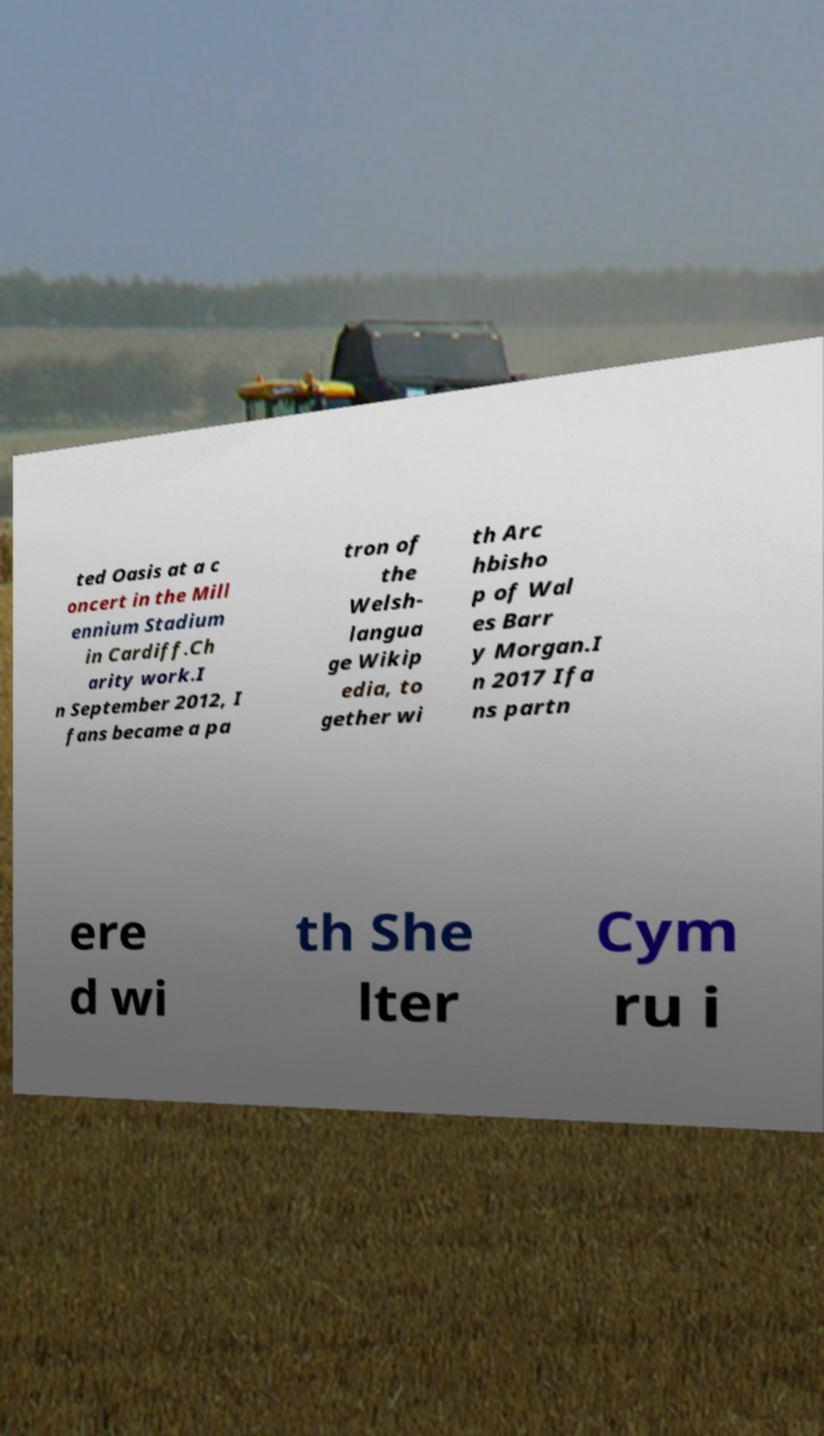Could you assist in decoding the text presented in this image and type it out clearly? ted Oasis at a c oncert in the Mill ennium Stadium in Cardiff.Ch arity work.I n September 2012, I fans became a pa tron of the Welsh- langua ge Wikip edia, to gether wi th Arc hbisho p of Wal es Barr y Morgan.I n 2017 Ifa ns partn ere d wi th She lter Cym ru i 